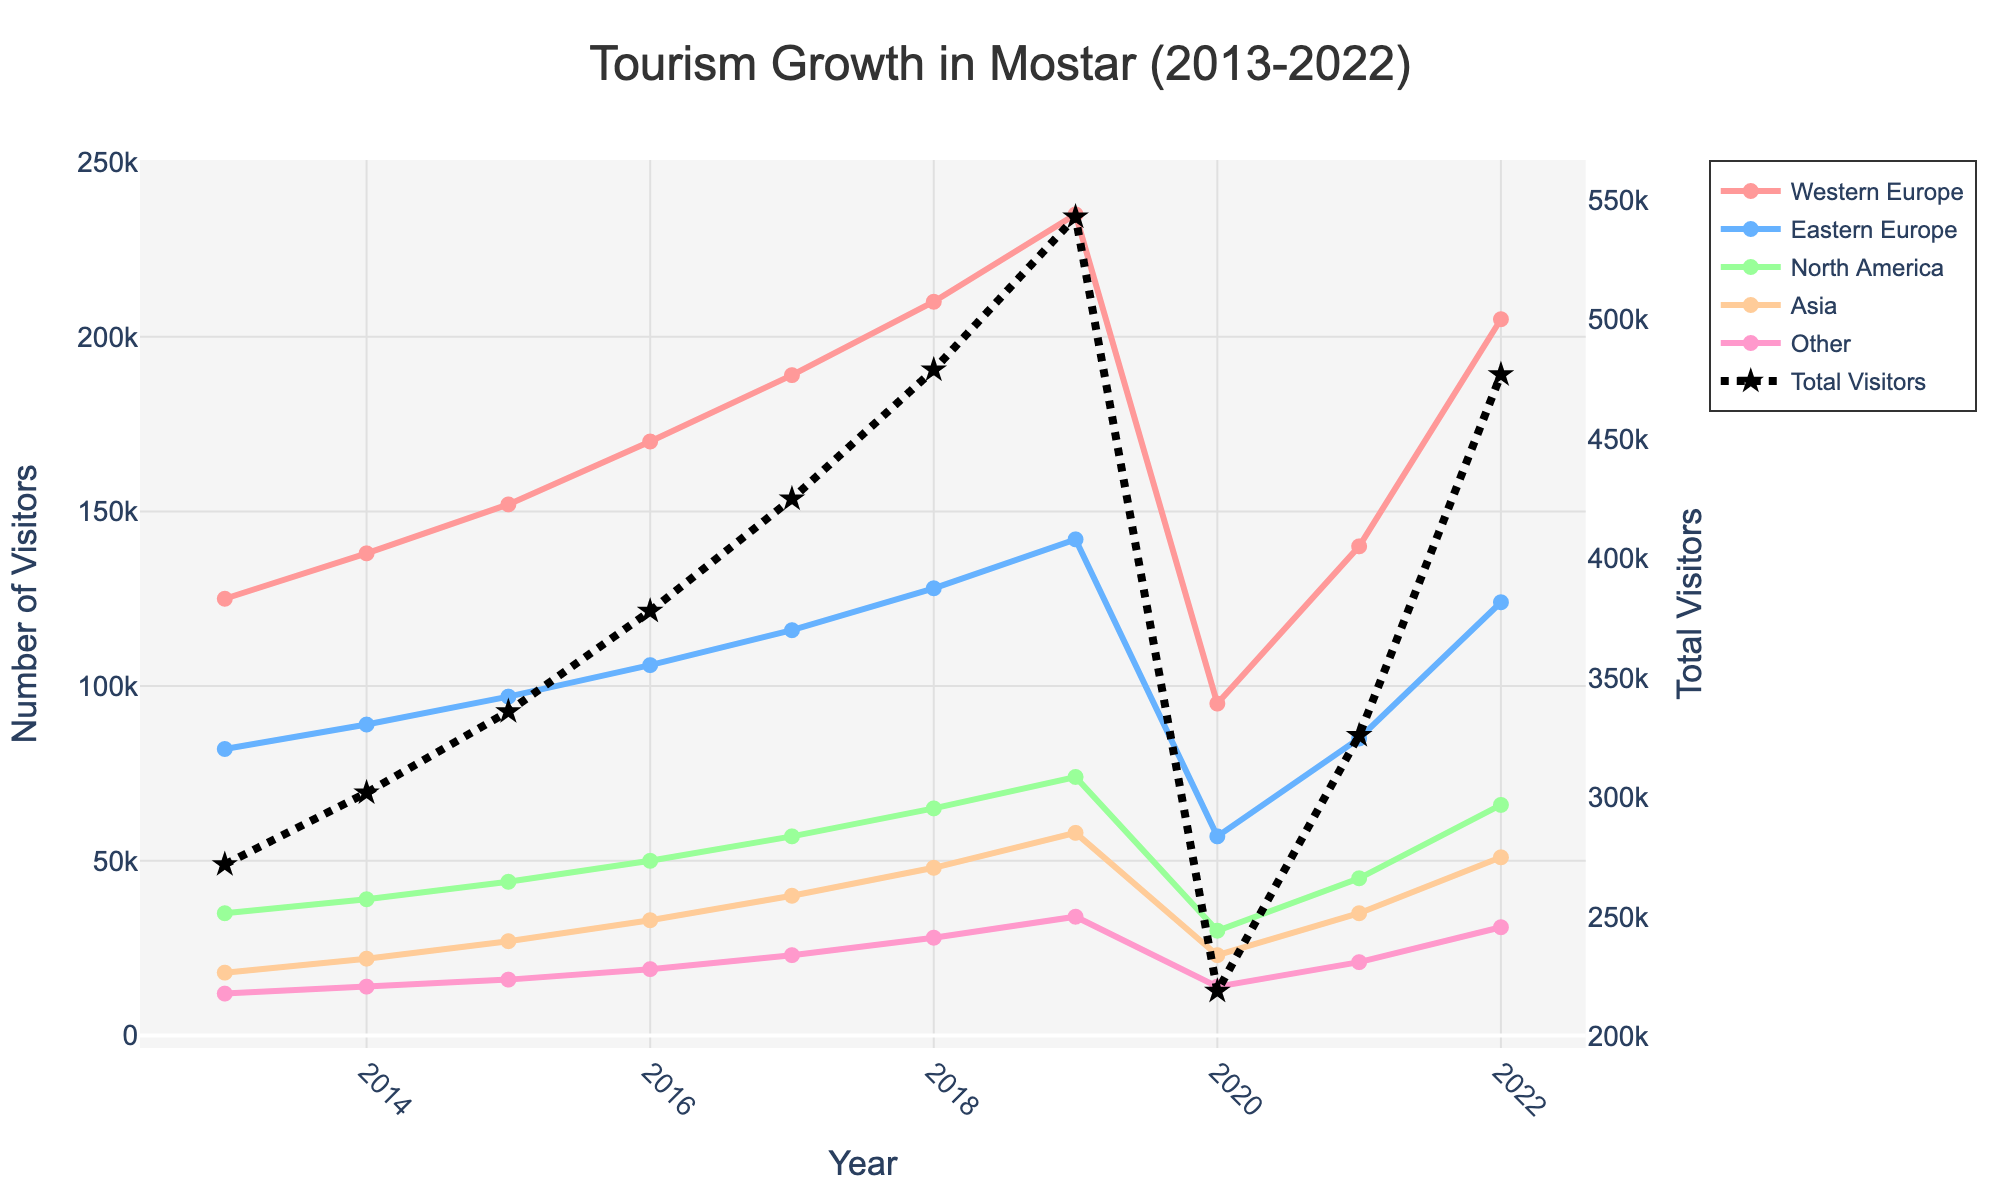What trend do you notice for visitors from North America from 2013 to 2022? North American visitor numbers steadily increased from 2013 to 2019, dropped in 2020, and then recovered somewhat by 2022.
Answer: Steady increase, drop in 2020, partial recovery by 2022 In which year did Mostar receive the highest number of visitors from Western Europe? Looking at the data provided, the highest number of visitors from Western Europe occurred in 2019, which reached 235,000.
Answer: 2019 Which region experienced the largest drop in visitor numbers in 2020? Comparing the visitor numbers from 2019 to 2020, Western Europe visitors dropped from 235,000 to 95,000, which is the largest drop among all regions.
Answer: Western Europe What is the total number of visitors in 2017 compared to 2022? In 2017, the total number of visitors from all regions combined is 325,000. In 2022, the total is 467,000. The total number increased by 142,000 from 2017 to 2022.
Answer: 467,000 in 2022, increased by 142,000 from 2017 How many visitors did Mostar receive from Asia in 2018 compared to 2021? In 2018, the number of visitors from Asia was 48,000, whereas in 2021 it was 35,000. Therefore, there were 13,000 fewer visitors from Asia in 2021 compared to 2018.
Answer: 48,000 in 2018, 13,000 fewer in 2021 Which year experienced a significant increase in visitors from Eastern Europe? The year with notable growth in Eastern European visitors is from 2018 to 2019 when the number increased from 128,000 to 142,000.
Answer: 2019 What can you infer about the trend of total visitors over the decade? The total visitor trend shows a general increase from 2013 to 2019, a sharp decline in 2020 due to a significant event, and a partial recovery through 2022.
Answer: General increase, sharp decline in 2020, partial recovery How do the numbers of visitors from North America in 2014 compare to those from Asia in the same year? In 2014, North American visitors were 39,000, while Asian visitors were 22,000. Hence, North American visitors were higher.
Answer: North America had more visitors What was the combined visitor number in 2015 from Western and Eastern Europe? For 2015, the number of visitors from Western Europe was 152,000 and from Eastern Europe was 97,000. Combining them yields 249,000.
Answer: 249,000 Compare the number of visitors from the "Other" category in 2020 to 2022. In 2020, the number of visitors from the "Other" category was 14,000, whereas in 2022 it increased to 31,000. The visitor number more than doubled by 2022.
Answer: More than doubled by 2022 